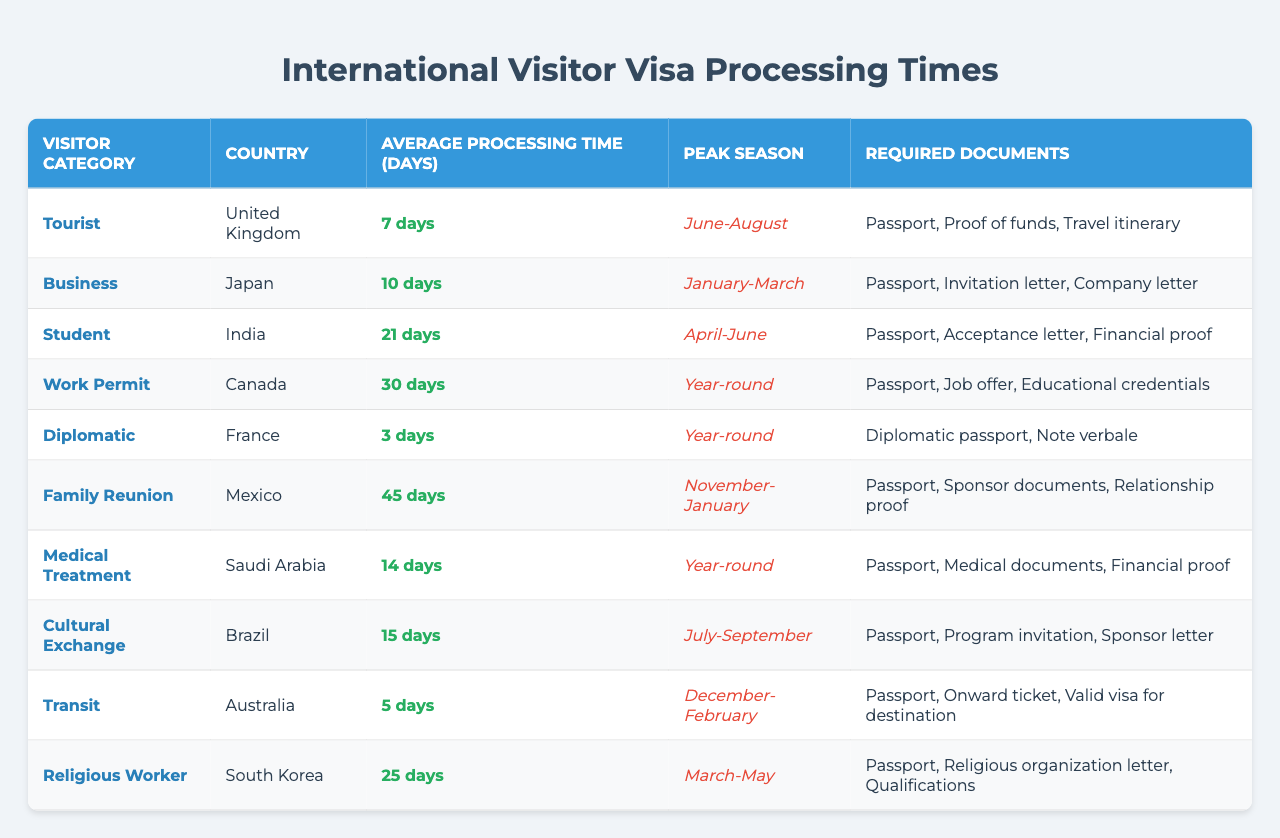What is the average processing time for a tourist visa from the United Kingdom? The processing time for a tourist visa from the United Kingdom is 7 days, as stated in the table.
Answer: 7 days Which visitor category has the longest average processing time? By reviewing the processing times for each category in the table, the Family Reunion category has the longest time at 45 days.
Answer: Family Reunion Is the processing time for a diplomatic visa shorter than that for a medical treatment visa? The processing time for a diplomatic visa from France is 3 days, while a medical treatment visa from Saudi Arabia takes 14 days. Since 3 is less than 14, the statement is true.
Answer: Yes What is the peak season for student visas from India? According to the table, the peak season for student visas from India is April to June.
Answer: April-June How many visitor categories have an average processing time greater than 20 days? The visitor categories with processing times greater than 20 days are Student (21), Work Permit (30), Family Reunion (45), and Religious Worker (25). Therefore, there are 4 categories.
Answer: 4 Which country has the shortest average processing time for a visa? The data indicates that the diplomatic visa to France has the shortest processing time of 3 days, which is less than any other category listed in the table.
Answer: France Calculate the average processing time for work permit and medical treatment visas. The processing time for the work permit is 30 days, and for medical treatment, it is 14 days. The average is calculated as (30 + 14) / 2 = 22 days.
Answer: 22 days Are there more visas with a peak season in summer than in winter? The peak seasons in summer are June-August (Tourist) and July-September (Cultural Exchange), totaling 2. The winter seasons are December-February (Transit) and November-January (Family Reunion), totaling 2 as well. Since both are equal, the answer is no.
Answer: No What types of visas require an invitation letter? Looking at the required documents for each visa, both Business (from Japan) and Cultural Exchange (from Brazil) require an invitation letter.
Answer: Business, Cultural Exchange Consider the processing times of all categories. What is the median processing time? First, we list the processing times: 3, 5, 7, 10, 14, 15, 21, 25, 30, 45. To find the median, we arrange them in order and identify the middle value(s). The two middle numbers (10 and 14) average to (10 + 14) / 2 = 12.
Answer: 12 days 